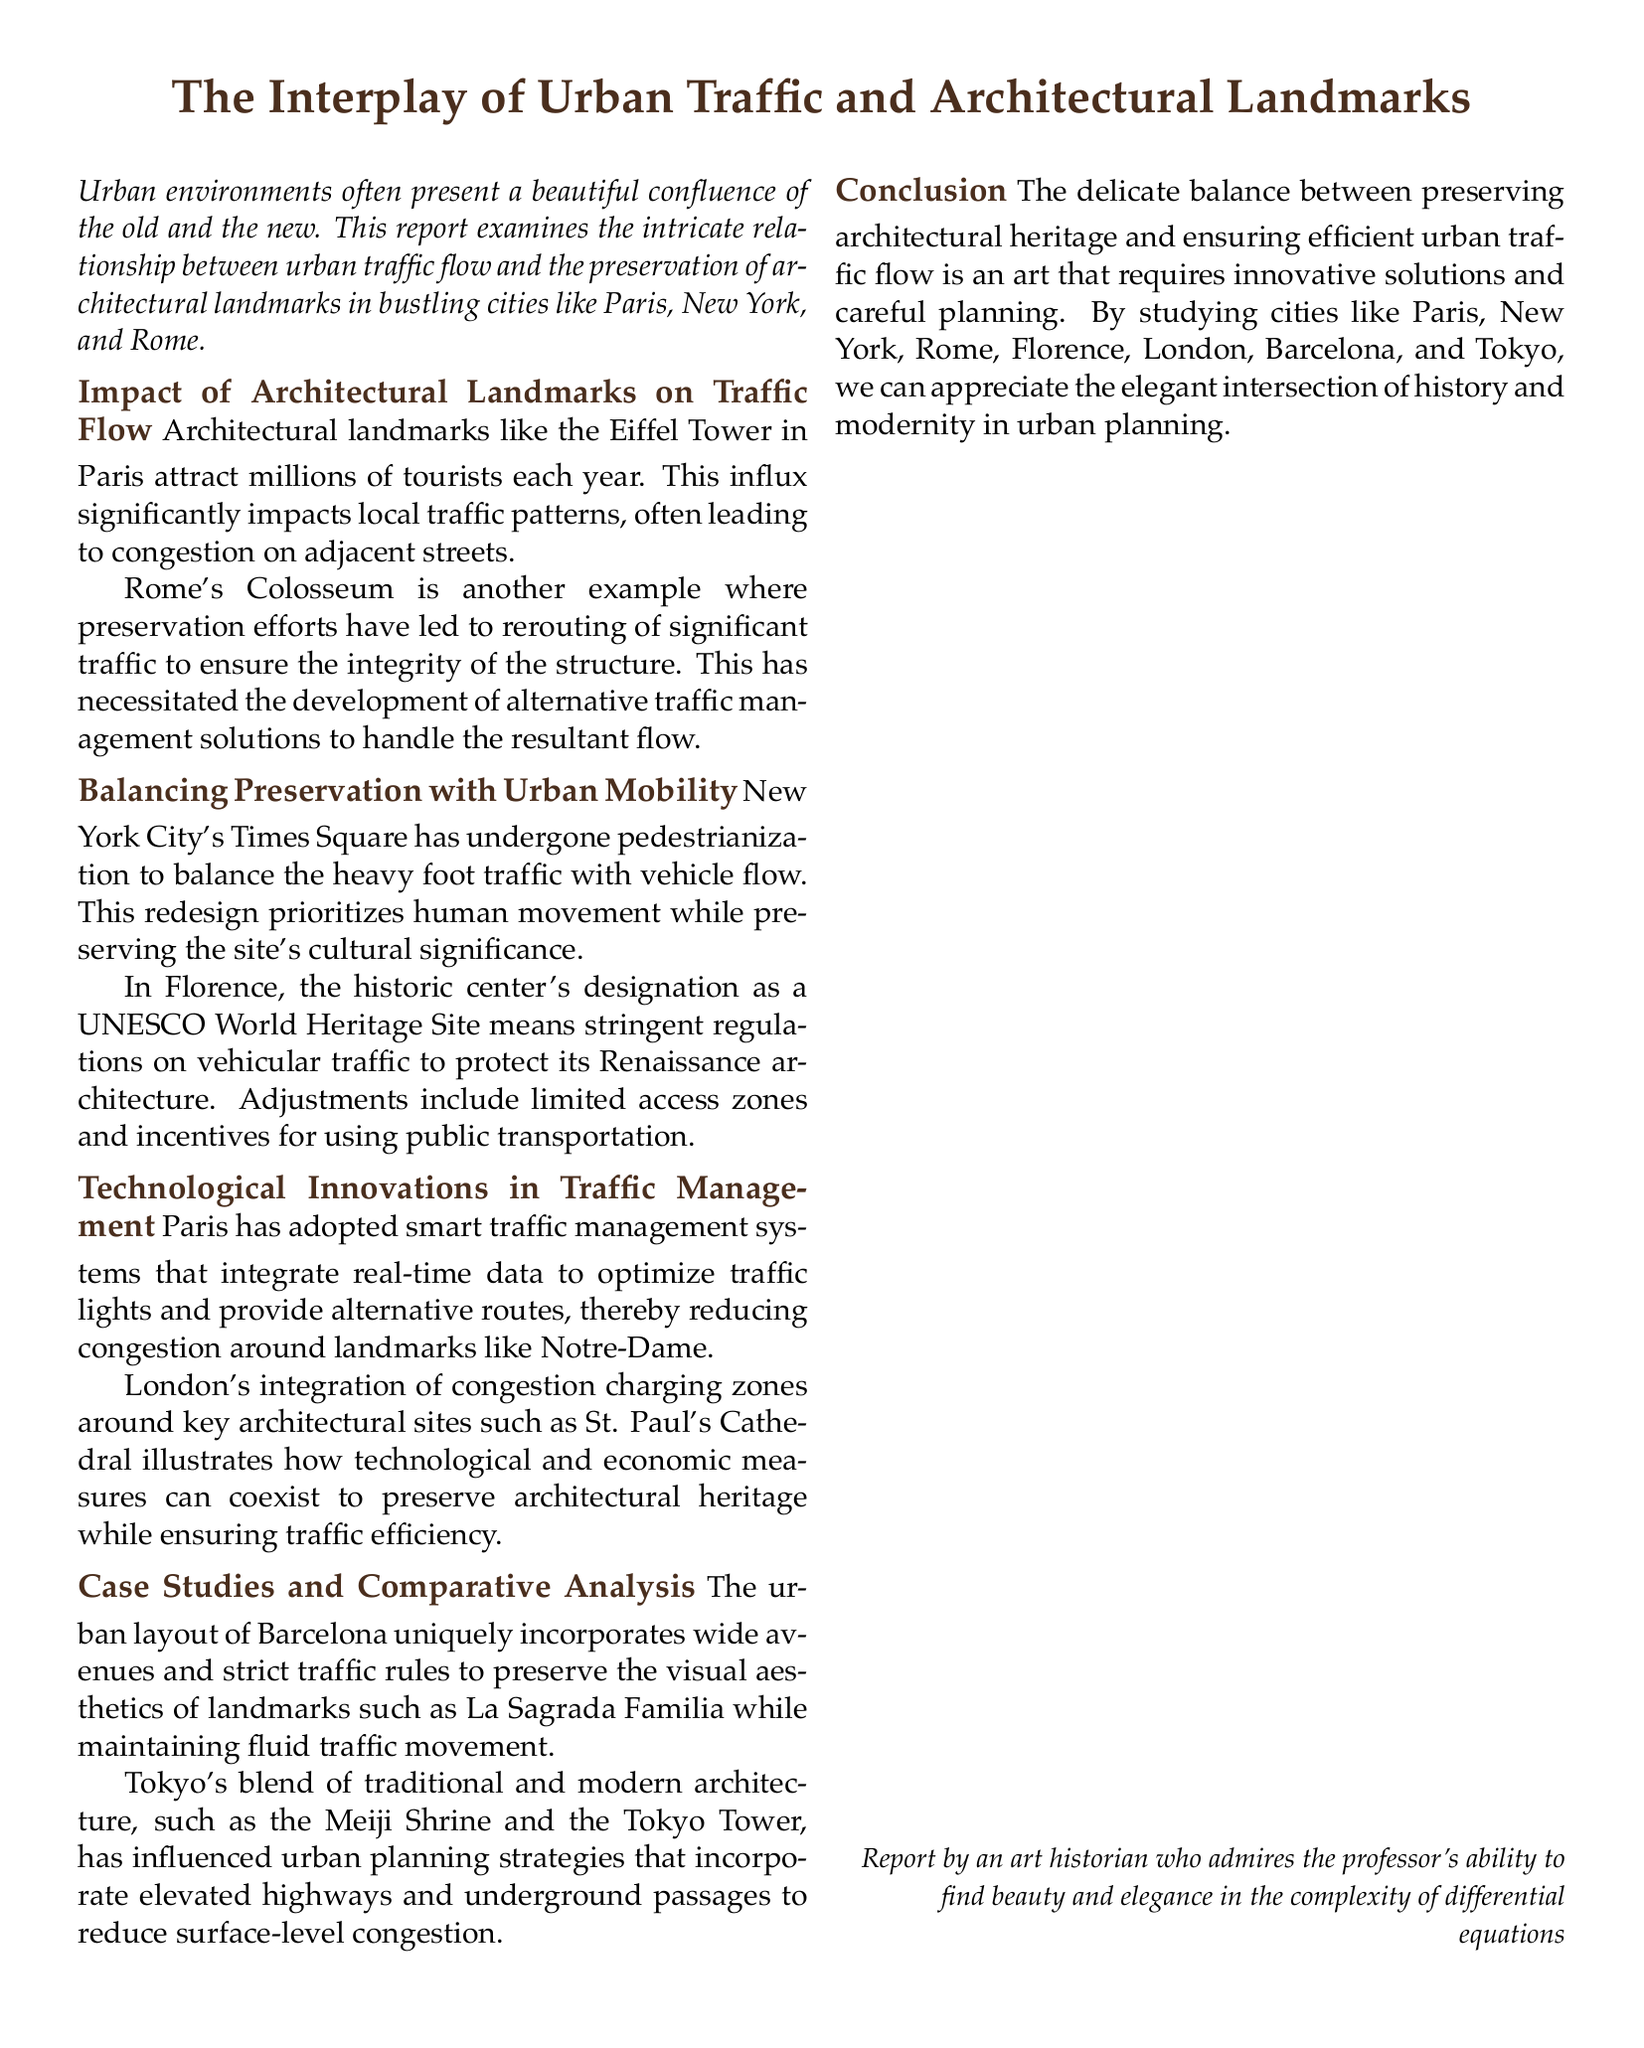What landmark is associated with heavy tourist traffic in Paris? The report mentions the Eiffel Tower as a significant architectural landmark that attracts millions of tourists.
Answer: Eiffel Tower What technology does Paris use for traffic management? The report states that Paris has adopted smart traffic management systems that optimize traffic flow using real-time data.
Answer: Smart traffic management systems Which city's historic center is a UNESCO World Heritage Site? The report indicates that Florence's historic center holds this designation, leading to strict traffic regulations.
Answer: Florence What architectural landmark is preserved through pedestrianization in New York City? The report highlights Times Square as a site where pedestrianization has been implemented to manage traffic flow.
Answer: Times Square What traffic management solution is utilized in London around key sites? The report mentions integration of congestion charging zones as a measure in London's traffic management.
Answer: Congestion charging zones What is the focus of the case study regarding Barcelona? Barcelona's urban layout is noted for its wide avenues and strict traffic rules aimed at preserving landmark aesthetics.
Answer: Preserving visual aesthetics Which two architectural sites are highlighted in Tokyo? The report refers to both the Meiji Shrine and the Tokyo Tower as significant traditional and modern sites in Tokyo.
Answer: Meiji Shrine and Tokyo Tower What is the overall theme of the report? The document examines the balance between preserving architectural heritage and maintaining efficient urban traffic flow.
Answer: Balance between preservation and traffic flow 